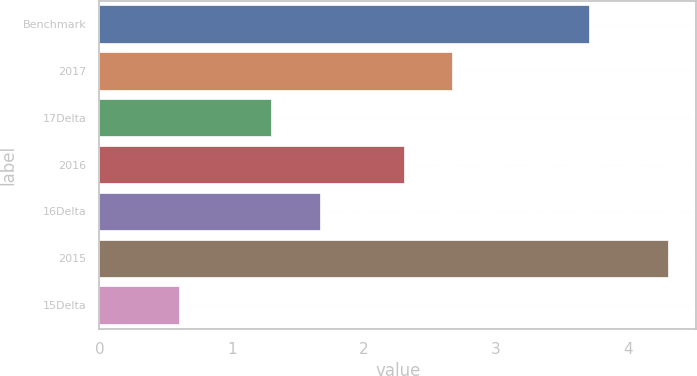Convert chart to OTSL. <chart><loc_0><loc_0><loc_500><loc_500><bar_chart><fcel>Benchmark<fcel>2017<fcel>17Delta<fcel>2016<fcel>16Delta<fcel>2015<fcel>15Delta<nl><fcel>3.7<fcel>2.67<fcel>1.3<fcel>2.3<fcel>1.67<fcel>4.3<fcel>0.6<nl></chart> 